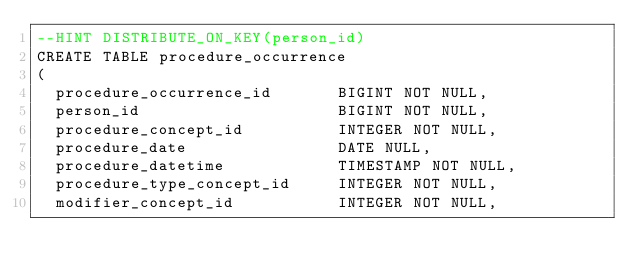<code> <loc_0><loc_0><loc_500><loc_500><_SQL_>--HINT DISTRIBUTE_ON_KEY(person_id)
CREATE TABLE procedure_occurrence
(
  procedure_occurrence_id       BIGINT NOT NULL,
  person_id                     BIGINT NOT NULL,
  procedure_concept_id          INTEGER NOT NULL,
  procedure_date                DATE NULL,
  procedure_datetime            TIMESTAMP NOT NULL,
  procedure_type_concept_id     INTEGER NOT NULL,
  modifier_concept_id           INTEGER NOT NULL,</code> 